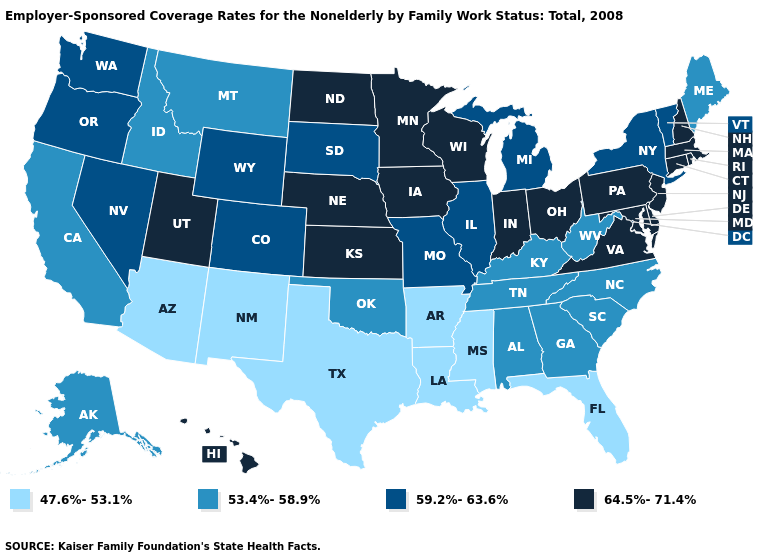Name the states that have a value in the range 59.2%-63.6%?
Concise answer only. Colorado, Illinois, Michigan, Missouri, Nevada, New York, Oregon, South Dakota, Vermont, Washington, Wyoming. Does the first symbol in the legend represent the smallest category?
Short answer required. Yes. Does Delaware have the lowest value in the USA?
Concise answer only. No. Does Alaska have the highest value in the West?
Short answer required. No. What is the value of Vermont?
Be succinct. 59.2%-63.6%. What is the value of Ohio?
Quick response, please. 64.5%-71.4%. Name the states that have a value in the range 64.5%-71.4%?
Be succinct. Connecticut, Delaware, Hawaii, Indiana, Iowa, Kansas, Maryland, Massachusetts, Minnesota, Nebraska, New Hampshire, New Jersey, North Dakota, Ohio, Pennsylvania, Rhode Island, Utah, Virginia, Wisconsin. Among the states that border Illinois , which have the lowest value?
Concise answer only. Kentucky. Does California have a lower value than Utah?
Quick response, please. Yes. Is the legend a continuous bar?
Keep it brief. No. What is the value of Georgia?
Keep it brief. 53.4%-58.9%. Among the states that border Iowa , does Missouri have the lowest value?
Answer briefly. Yes. Name the states that have a value in the range 64.5%-71.4%?
Write a very short answer. Connecticut, Delaware, Hawaii, Indiana, Iowa, Kansas, Maryland, Massachusetts, Minnesota, Nebraska, New Hampshire, New Jersey, North Dakota, Ohio, Pennsylvania, Rhode Island, Utah, Virginia, Wisconsin. What is the value of Alabama?
Quick response, please. 53.4%-58.9%. Name the states that have a value in the range 53.4%-58.9%?
Short answer required. Alabama, Alaska, California, Georgia, Idaho, Kentucky, Maine, Montana, North Carolina, Oklahoma, South Carolina, Tennessee, West Virginia. 